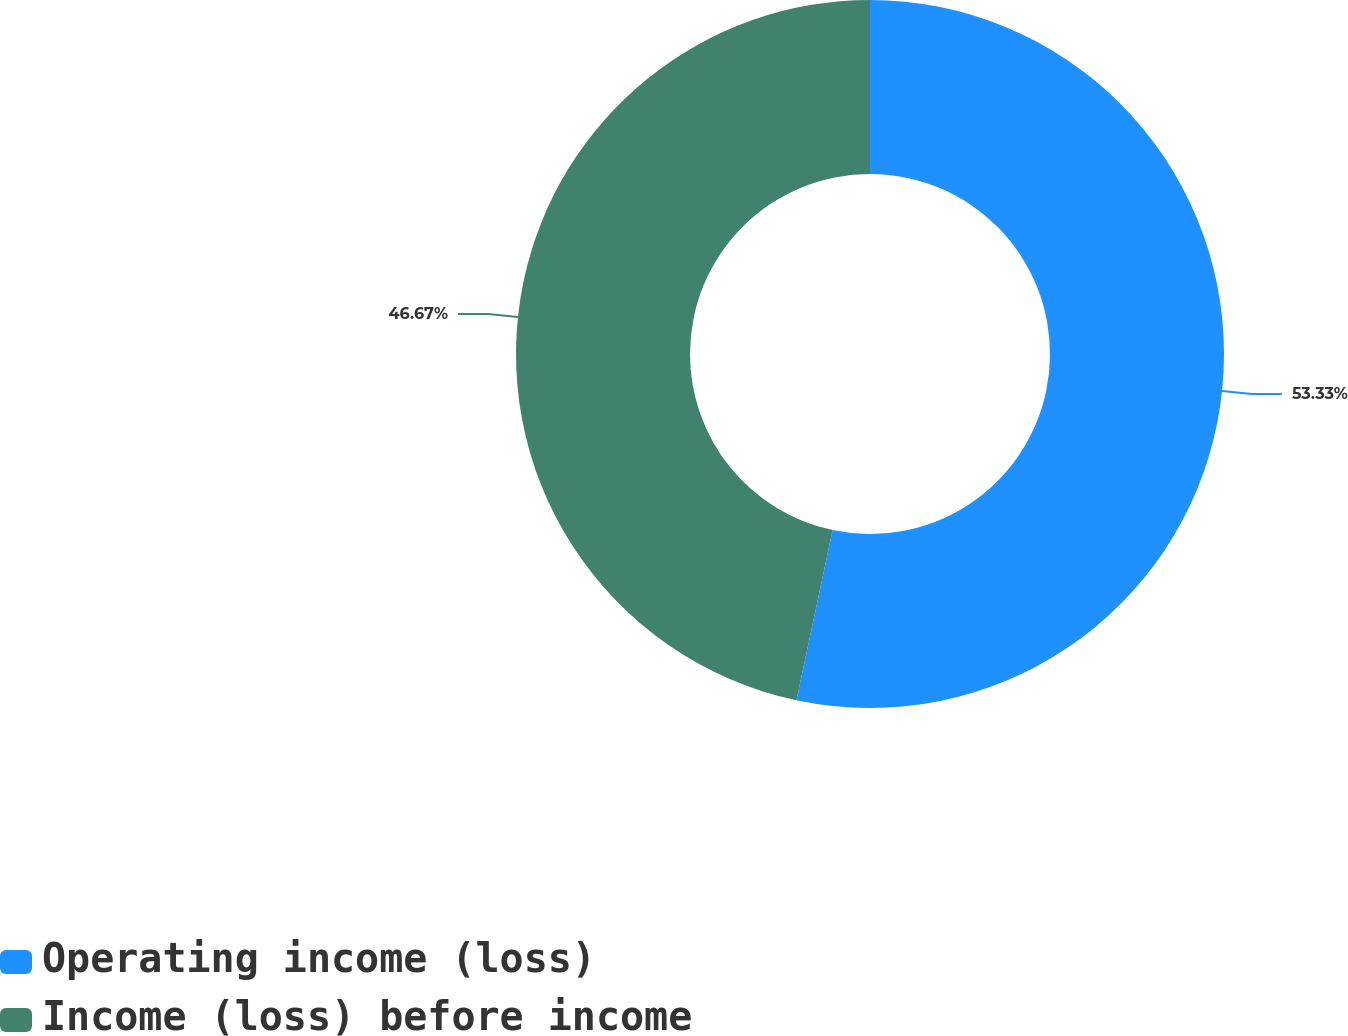<chart> <loc_0><loc_0><loc_500><loc_500><pie_chart><fcel>Operating income (loss)<fcel>Income (loss) before income<nl><fcel>53.33%<fcel>46.67%<nl></chart> 